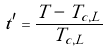Convert formula to latex. <formula><loc_0><loc_0><loc_500><loc_500>t ^ { \prime } = \frac { T - T _ { c , L } } { T _ { c , L } }</formula> 